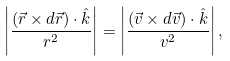Convert formula to latex. <formula><loc_0><loc_0><loc_500><loc_500>\left | \frac { ( \vec { r } \times d \vec { r } ) \cdot \hat { k } } { r ^ { 2 } } \right | = \left | \frac { ( \vec { v } \times d \vec { v } ) \cdot \hat { k } } { v ^ { 2 } } \right | ,</formula> 